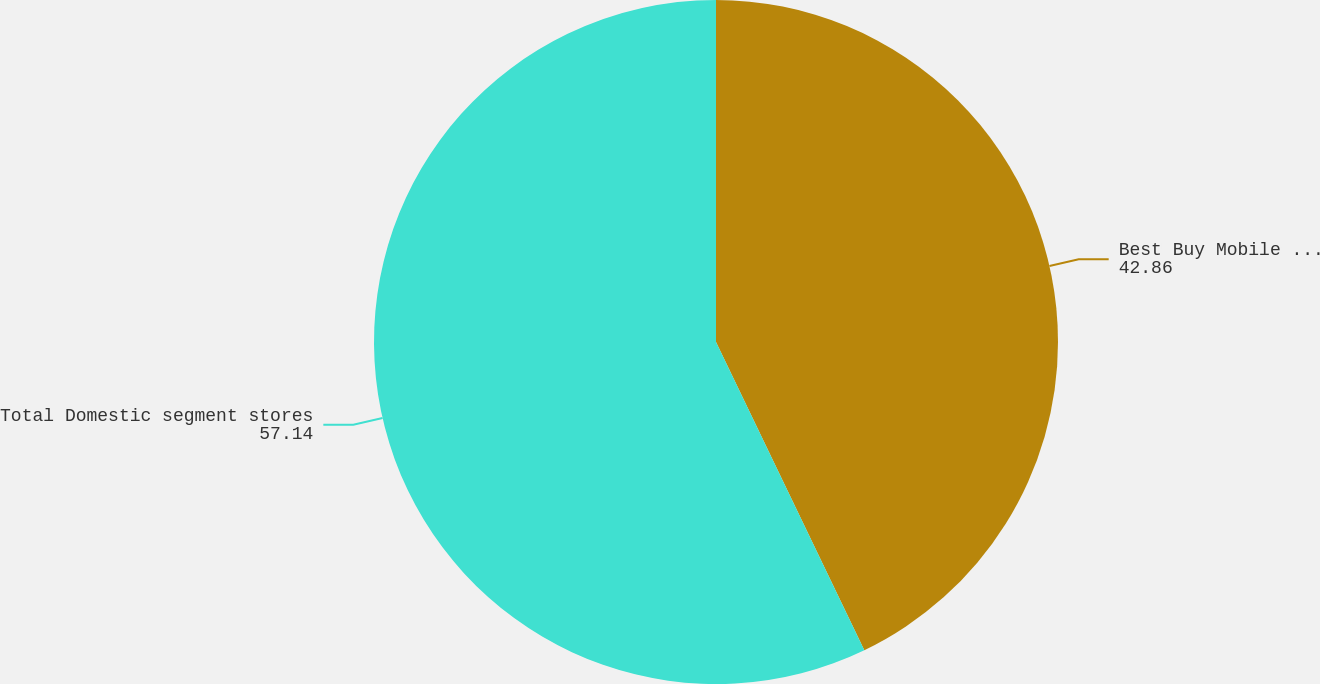<chart> <loc_0><loc_0><loc_500><loc_500><pie_chart><fcel>Best Buy Mobile stand-alone<fcel>Total Domestic segment stores<nl><fcel>42.86%<fcel>57.14%<nl></chart> 